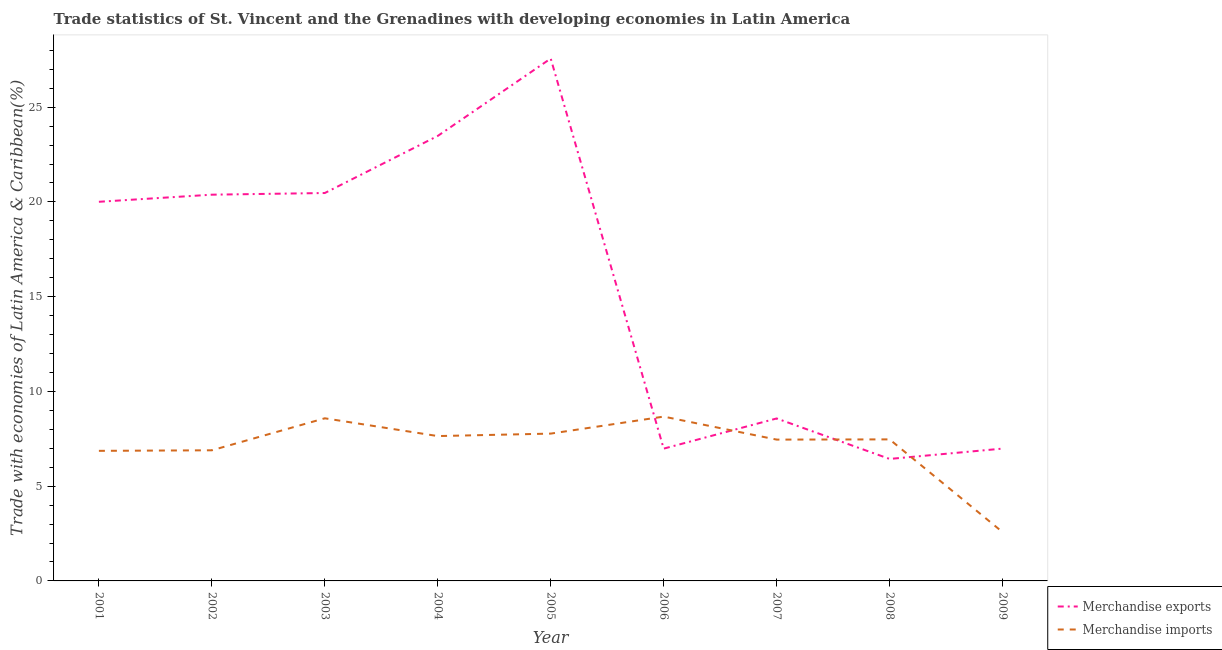Is the number of lines equal to the number of legend labels?
Offer a terse response. Yes. What is the merchandise imports in 2007?
Ensure brevity in your answer.  7.46. Across all years, what is the maximum merchandise imports?
Provide a succinct answer. 8.67. Across all years, what is the minimum merchandise imports?
Ensure brevity in your answer.  2.58. In which year was the merchandise imports maximum?
Offer a terse response. 2006. What is the total merchandise imports in the graph?
Make the answer very short. 63.94. What is the difference between the merchandise imports in 2003 and that in 2007?
Provide a short and direct response. 1.12. What is the difference between the merchandise imports in 2006 and the merchandise exports in 2001?
Your answer should be very brief. -11.34. What is the average merchandise exports per year?
Offer a very short reply. 15.65. In the year 2006, what is the difference between the merchandise exports and merchandise imports?
Your response must be concise. -1.69. In how many years, is the merchandise imports greater than 19 %?
Provide a short and direct response. 0. What is the ratio of the merchandise exports in 2001 to that in 2009?
Your answer should be very brief. 2.87. Is the merchandise imports in 2002 less than that in 2008?
Keep it short and to the point. Yes. What is the difference between the highest and the second highest merchandise exports?
Your response must be concise. 4.08. What is the difference between the highest and the lowest merchandise imports?
Your answer should be compact. 6.09. Is the sum of the merchandise exports in 2002 and 2008 greater than the maximum merchandise imports across all years?
Provide a succinct answer. Yes. Does the merchandise imports monotonically increase over the years?
Offer a terse response. No. How many years are there in the graph?
Your answer should be compact. 9. Are the values on the major ticks of Y-axis written in scientific E-notation?
Provide a short and direct response. No. Does the graph contain grids?
Offer a very short reply. No. What is the title of the graph?
Offer a very short reply. Trade statistics of St. Vincent and the Grenadines with developing economies in Latin America. What is the label or title of the X-axis?
Make the answer very short. Year. What is the label or title of the Y-axis?
Give a very brief answer. Trade with economies of Latin America & Caribbean(%). What is the Trade with economies of Latin America & Caribbean(%) in Merchandise exports in 2001?
Offer a terse response. 20.01. What is the Trade with economies of Latin America & Caribbean(%) in Merchandise imports in 2001?
Your answer should be very brief. 6.86. What is the Trade with economies of Latin America & Caribbean(%) in Merchandise exports in 2002?
Keep it short and to the point. 20.38. What is the Trade with economies of Latin America & Caribbean(%) in Merchandise imports in 2002?
Keep it short and to the point. 6.89. What is the Trade with economies of Latin America & Caribbean(%) in Merchandise exports in 2003?
Offer a very short reply. 20.47. What is the Trade with economies of Latin America & Caribbean(%) in Merchandise imports in 2003?
Give a very brief answer. 8.58. What is the Trade with economies of Latin America & Caribbean(%) of Merchandise exports in 2004?
Your answer should be compact. 23.48. What is the Trade with economies of Latin America & Caribbean(%) in Merchandise imports in 2004?
Keep it short and to the point. 7.64. What is the Trade with economies of Latin America & Caribbean(%) of Merchandise exports in 2005?
Make the answer very short. 27.57. What is the Trade with economies of Latin America & Caribbean(%) in Merchandise imports in 2005?
Offer a very short reply. 7.77. What is the Trade with economies of Latin America & Caribbean(%) of Merchandise exports in 2006?
Provide a short and direct response. 6.98. What is the Trade with economies of Latin America & Caribbean(%) of Merchandise imports in 2006?
Provide a succinct answer. 8.67. What is the Trade with economies of Latin America & Caribbean(%) of Merchandise exports in 2007?
Offer a very short reply. 8.57. What is the Trade with economies of Latin America & Caribbean(%) in Merchandise imports in 2007?
Your response must be concise. 7.46. What is the Trade with economies of Latin America & Caribbean(%) of Merchandise exports in 2008?
Give a very brief answer. 6.44. What is the Trade with economies of Latin America & Caribbean(%) of Merchandise imports in 2008?
Your response must be concise. 7.47. What is the Trade with economies of Latin America & Caribbean(%) in Merchandise exports in 2009?
Your response must be concise. 6.98. What is the Trade with economies of Latin America & Caribbean(%) in Merchandise imports in 2009?
Provide a short and direct response. 2.58. Across all years, what is the maximum Trade with economies of Latin America & Caribbean(%) in Merchandise exports?
Make the answer very short. 27.57. Across all years, what is the maximum Trade with economies of Latin America & Caribbean(%) in Merchandise imports?
Your answer should be compact. 8.67. Across all years, what is the minimum Trade with economies of Latin America & Caribbean(%) of Merchandise exports?
Make the answer very short. 6.44. Across all years, what is the minimum Trade with economies of Latin America & Caribbean(%) of Merchandise imports?
Provide a short and direct response. 2.58. What is the total Trade with economies of Latin America & Caribbean(%) of Merchandise exports in the graph?
Give a very brief answer. 140.89. What is the total Trade with economies of Latin America & Caribbean(%) of Merchandise imports in the graph?
Your answer should be very brief. 63.94. What is the difference between the Trade with economies of Latin America & Caribbean(%) in Merchandise exports in 2001 and that in 2002?
Keep it short and to the point. -0.37. What is the difference between the Trade with economies of Latin America & Caribbean(%) of Merchandise imports in 2001 and that in 2002?
Your answer should be very brief. -0.03. What is the difference between the Trade with economies of Latin America & Caribbean(%) in Merchandise exports in 2001 and that in 2003?
Ensure brevity in your answer.  -0.46. What is the difference between the Trade with economies of Latin America & Caribbean(%) in Merchandise imports in 2001 and that in 2003?
Provide a short and direct response. -1.72. What is the difference between the Trade with economies of Latin America & Caribbean(%) in Merchandise exports in 2001 and that in 2004?
Offer a very short reply. -3.48. What is the difference between the Trade with economies of Latin America & Caribbean(%) of Merchandise imports in 2001 and that in 2004?
Your answer should be very brief. -0.78. What is the difference between the Trade with economies of Latin America & Caribbean(%) of Merchandise exports in 2001 and that in 2005?
Provide a succinct answer. -7.56. What is the difference between the Trade with economies of Latin America & Caribbean(%) in Merchandise imports in 2001 and that in 2005?
Keep it short and to the point. -0.91. What is the difference between the Trade with economies of Latin America & Caribbean(%) of Merchandise exports in 2001 and that in 2006?
Provide a succinct answer. 13.03. What is the difference between the Trade with economies of Latin America & Caribbean(%) of Merchandise imports in 2001 and that in 2006?
Your answer should be very brief. -1.81. What is the difference between the Trade with economies of Latin America & Caribbean(%) in Merchandise exports in 2001 and that in 2007?
Make the answer very short. 11.44. What is the difference between the Trade with economies of Latin America & Caribbean(%) of Merchandise imports in 2001 and that in 2007?
Offer a terse response. -0.59. What is the difference between the Trade with economies of Latin America & Caribbean(%) in Merchandise exports in 2001 and that in 2008?
Offer a very short reply. 13.57. What is the difference between the Trade with economies of Latin America & Caribbean(%) in Merchandise imports in 2001 and that in 2008?
Provide a succinct answer. -0.6. What is the difference between the Trade with economies of Latin America & Caribbean(%) of Merchandise exports in 2001 and that in 2009?
Ensure brevity in your answer.  13.03. What is the difference between the Trade with economies of Latin America & Caribbean(%) of Merchandise imports in 2001 and that in 2009?
Your answer should be very brief. 4.29. What is the difference between the Trade with economies of Latin America & Caribbean(%) in Merchandise exports in 2002 and that in 2003?
Make the answer very short. -0.09. What is the difference between the Trade with economies of Latin America & Caribbean(%) of Merchandise imports in 2002 and that in 2003?
Your answer should be very brief. -1.69. What is the difference between the Trade with economies of Latin America & Caribbean(%) of Merchandise exports in 2002 and that in 2004?
Your response must be concise. -3.1. What is the difference between the Trade with economies of Latin America & Caribbean(%) in Merchandise imports in 2002 and that in 2004?
Keep it short and to the point. -0.75. What is the difference between the Trade with economies of Latin America & Caribbean(%) of Merchandise exports in 2002 and that in 2005?
Provide a succinct answer. -7.18. What is the difference between the Trade with economies of Latin America & Caribbean(%) of Merchandise imports in 2002 and that in 2005?
Make the answer very short. -0.88. What is the difference between the Trade with economies of Latin America & Caribbean(%) in Merchandise exports in 2002 and that in 2006?
Offer a very short reply. 13.4. What is the difference between the Trade with economies of Latin America & Caribbean(%) of Merchandise imports in 2002 and that in 2006?
Your answer should be compact. -1.78. What is the difference between the Trade with economies of Latin America & Caribbean(%) of Merchandise exports in 2002 and that in 2007?
Your answer should be compact. 11.81. What is the difference between the Trade with economies of Latin America & Caribbean(%) in Merchandise imports in 2002 and that in 2007?
Your answer should be compact. -0.56. What is the difference between the Trade with economies of Latin America & Caribbean(%) of Merchandise exports in 2002 and that in 2008?
Ensure brevity in your answer.  13.95. What is the difference between the Trade with economies of Latin America & Caribbean(%) in Merchandise imports in 2002 and that in 2008?
Make the answer very short. -0.58. What is the difference between the Trade with economies of Latin America & Caribbean(%) of Merchandise exports in 2002 and that in 2009?
Provide a short and direct response. 13.4. What is the difference between the Trade with economies of Latin America & Caribbean(%) of Merchandise imports in 2002 and that in 2009?
Your answer should be compact. 4.32. What is the difference between the Trade with economies of Latin America & Caribbean(%) of Merchandise exports in 2003 and that in 2004?
Your response must be concise. -3.01. What is the difference between the Trade with economies of Latin America & Caribbean(%) in Merchandise imports in 2003 and that in 2004?
Keep it short and to the point. 0.94. What is the difference between the Trade with economies of Latin America & Caribbean(%) of Merchandise exports in 2003 and that in 2005?
Ensure brevity in your answer.  -7.1. What is the difference between the Trade with economies of Latin America & Caribbean(%) in Merchandise imports in 2003 and that in 2005?
Offer a terse response. 0.81. What is the difference between the Trade with economies of Latin America & Caribbean(%) of Merchandise exports in 2003 and that in 2006?
Offer a terse response. 13.49. What is the difference between the Trade with economies of Latin America & Caribbean(%) in Merchandise imports in 2003 and that in 2006?
Give a very brief answer. -0.09. What is the difference between the Trade with economies of Latin America & Caribbean(%) in Merchandise exports in 2003 and that in 2007?
Offer a very short reply. 11.9. What is the difference between the Trade with economies of Latin America & Caribbean(%) in Merchandise imports in 2003 and that in 2007?
Your response must be concise. 1.12. What is the difference between the Trade with economies of Latin America & Caribbean(%) of Merchandise exports in 2003 and that in 2008?
Provide a succinct answer. 14.03. What is the difference between the Trade with economies of Latin America & Caribbean(%) in Merchandise imports in 2003 and that in 2008?
Your answer should be compact. 1.11. What is the difference between the Trade with economies of Latin America & Caribbean(%) of Merchandise exports in 2003 and that in 2009?
Your response must be concise. 13.49. What is the difference between the Trade with economies of Latin America & Caribbean(%) of Merchandise imports in 2003 and that in 2009?
Provide a succinct answer. 6.01. What is the difference between the Trade with economies of Latin America & Caribbean(%) in Merchandise exports in 2004 and that in 2005?
Make the answer very short. -4.08. What is the difference between the Trade with economies of Latin America & Caribbean(%) of Merchandise imports in 2004 and that in 2005?
Your answer should be compact. -0.13. What is the difference between the Trade with economies of Latin America & Caribbean(%) in Merchandise exports in 2004 and that in 2006?
Your response must be concise. 16.5. What is the difference between the Trade with economies of Latin America & Caribbean(%) in Merchandise imports in 2004 and that in 2006?
Your answer should be very brief. -1.03. What is the difference between the Trade with economies of Latin America & Caribbean(%) in Merchandise exports in 2004 and that in 2007?
Offer a terse response. 14.91. What is the difference between the Trade with economies of Latin America & Caribbean(%) of Merchandise imports in 2004 and that in 2007?
Provide a succinct answer. 0.19. What is the difference between the Trade with economies of Latin America & Caribbean(%) of Merchandise exports in 2004 and that in 2008?
Ensure brevity in your answer.  17.05. What is the difference between the Trade with economies of Latin America & Caribbean(%) of Merchandise imports in 2004 and that in 2008?
Ensure brevity in your answer.  0.17. What is the difference between the Trade with economies of Latin America & Caribbean(%) in Merchandise exports in 2004 and that in 2009?
Ensure brevity in your answer.  16.5. What is the difference between the Trade with economies of Latin America & Caribbean(%) in Merchandise imports in 2004 and that in 2009?
Offer a terse response. 5.07. What is the difference between the Trade with economies of Latin America & Caribbean(%) in Merchandise exports in 2005 and that in 2006?
Your answer should be very brief. 20.59. What is the difference between the Trade with economies of Latin America & Caribbean(%) in Merchandise imports in 2005 and that in 2006?
Make the answer very short. -0.9. What is the difference between the Trade with economies of Latin America & Caribbean(%) in Merchandise exports in 2005 and that in 2007?
Ensure brevity in your answer.  18.99. What is the difference between the Trade with economies of Latin America & Caribbean(%) of Merchandise imports in 2005 and that in 2007?
Offer a very short reply. 0.32. What is the difference between the Trade with economies of Latin America & Caribbean(%) of Merchandise exports in 2005 and that in 2008?
Ensure brevity in your answer.  21.13. What is the difference between the Trade with economies of Latin America & Caribbean(%) in Merchandise imports in 2005 and that in 2008?
Make the answer very short. 0.3. What is the difference between the Trade with economies of Latin America & Caribbean(%) in Merchandise exports in 2005 and that in 2009?
Ensure brevity in your answer.  20.58. What is the difference between the Trade with economies of Latin America & Caribbean(%) of Merchandise imports in 2005 and that in 2009?
Your answer should be compact. 5.2. What is the difference between the Trade with economies of Latin America & Caribbean(%) in Merchandise exports in 2006 and that in 2007?
Make the answer very short. -1.59. What is the difference between the Trade with economies of Latin America & Caribbean(%) in Merchandise imports in 2006 and that in 2007?
Make the answer very short. 1.21. What is the difference between the Trade with economies of Latin America & Caribbean(%) of Merchandise exports in 2006 and that in 2008?
Your answer should be compact. 0.54. What is the difference between the Trade with economies of Latin America & Caribbean(%) in Merchandise imports in 2006 and that in 2008?
Offer a terse response. 1.2. What is the difference between the Trade with economies of Latin America & Caribbean(%) of Merchandise exports in 2006 and that in 2009?
Keep it short and to the point. -0. What is the difference between the Trade with economies of Latin America & Caribbean(%) of Merchandise imports in 2006 and that in 2009?
Offer a very short reply. 6.09. What is the difference between the Trade with economies of Latin America & Caribbean(%) of Merchandise exports in 2007 and that in 2008?
Provide a succinct answer. 2.14. What is the difference between the Trade with economies of Latin America & Caribbean(%) in Merchandise imports in 2007 and that in 2008?
Provide a succinct answer. -0.01. What is the difference between the Trade with economies of Latin America & Caribbean(%) of Merchandise exports in 2007 and that in 2009?
Offer a terse response. 1.59. What is the difference between the Trade with economies of Latin America & Caribbean(%) in Merchandise imports in 2007 and that in 2009?
Make the answer very short. 4.88. What is the difference between the Trade with economies of Latin America & Caribbean(%) in Merchandise exports in 2008 and that in 2009?
Make the answer very short. -0.54. What is the difference between the Trade with economies of Latin America & Caribbean(%) in Merchandise imports in 2008 and that in 2009?
Make the answer very short. 4.89. What is the difference between the Trade with economies of Latin America & Caribbean(%) of Merchandise exports in 2001 and the Trade with economies of Latin America & Caribbean(%) of Merchandise imports in 2002?
Ensure brevity in your answer.  13.11. What is the difference between the Trade with economies of Latin America & Caribbean(%) of Merchandise exports in 2001 and the Trade with economies of Latin America & Caribbean(%) of Merchandise imports in 2003?
Keep it short and to the point. 11.43. What is the difference between the Trade with economies of Latin America & Caribbean(%) in Merchandise exports in 2001 and the Trade with economies of Latin America & Caribbean(%) in Merchandise imports in 2004?
Give a very brief answer. 12.36. What is the difference between the Trade with economies of Latin America & Caribbean(%) of Merchandise exports in 2001 and the Trade with economies of Latin America & Caribbean(%) of Merchandise imports in 2005?
Provide a succinct answer. 12.23. What is the difference between the Trade with economies of Latin America & Caribbean(%) of Merchandise exports in 2001 and the Trade with economies of Latin America & Caribbean(%) of Merchandise imports in 2006?
Provide a short and direct response. 11.34. What is the difference between the Trade with economies of Latin America & Caribbean(%) of Merchandise exports in 2001 and the Trade with economies of Latin America & Caribbean(%) of Merchandise imports in 2007?
Your answer should be very brief. 12.55. What is the difference between the Trade with economies of Latin America & Caribbean(%) of Merchandise exports in 2001 and the Trade with economies of Latin America & Caribbean(%) of Merchandise imports in 2008?
Keep it short and to the point. 12.54. What is the difference between the Trade with economies of Latin America & Caribbean(%) in Merchandise exports in 2001 and the Trade with economies of Latin America & Caribbean(%) in Merchandise imports in 2009?
Keep it short and to the point. 17.43. What is the difference between the Trade with economies of Latin America & Caribbean(%) of Merchandise exports in 2002 and the Trade with economies of Latin America & Caribbean(%) of Merchandise imports in 2003?
Offer a very short reply. 11.8. What is the difference between the Trade with economies of Latin America & Caribbean(%) of Merchandise exports in 2002 and the Trade with economies of Latin America & Caribbean(%) of Merchandise imports in 2004?
Provide a succinct answer. 12.74. What is the difference between the Trade with economies of Latin America & Caribbean(%) of Merchandise exports in 2002 and the Trade with economies of Latin America & Caribbean(%) of Merchandise imports in 2005?
Your answer should be very brief. 12.61. What is the difference between the Trade with economies of Latin America & Caribbean(%) of Merchandise exports in 2002 and the Trade with economies of Latin America & Caribbean(%) of Merchandise imports in 2006?
Provide a succinct answer. 11.71. What is the difference between the Trade with economies of Latin America & Caribbean(%) in Merchandise exports in 2002 and the Trade with economies of Latin America & Caribbean(%) in Merchandise imports in 2007?
Provide a short and direct response. 12.93. What is the difference between the Trade with economies of Latin America & Caribbean(%) in Merchandise exports in 2002 and the Trade with economies of Latin America & Caribbean(%) in Merchandise imports in 2008?
Keep it short and to the point. 12.91. What is the difference between the Trade with economies of Latin America & Caribbean(%) in Merchandise exports in 2002 and the Trade with economies of Latin America & Caribbean(%) in Merchandise imports in 2009?
Offer a terse response. 17.81. What is the difference between the Trade with economies of Latin America & Caribbean(%) of Merchandise exports in 2003 and the Trade with economies of Latin America & Caribbean(%) of Merchandise imports in 2004?
Offer a terse response. 12.83. What is the difference between the Trade with economies of Latin America & Caribbean(%) of Merchandise exports in 2003 and the Trade with economies of Latin America & Caribbean(%) of Merchandise imports in 2005?
Give a very brief answer. 12.7. What is the difference between the Trade with economies of Latin America & Caribbean(%) in Merchandise exports in 2003 and the Trade with economies of Latin America & Caribbean(%) in Merchandise imports in 2006?
Your answer should be compact. 11.8. What is the difference between the Trade with economies of Latin America & Caribbean(%) of Merchandise exports in 2003 and the Trade with economies of Latin America & Caribbean(%) of Merchandise imports in 2007?
Your answer should be compact. 13.01. What is the difference between the Trade with economies of Latin America & Caribbean(%) in Merchandise exports in 2003 and the Trade with economies of Latin America & Caribbean(%) in Merchandise imports in 2008?
Keep it short and to the point. 13. What is the difference between the Trade with economies of Latin America & Caribbean(%) of Merchandise exports in 2003 and the Trade with economies of Latin America & Caribbean(%) of Merchandise imports in 2009?
Ensure brevity in your answer.  17.89. What is the difference between the Trade with economies of Latin America & Caribbean(%) in Merchandise exports in 2004 and the Trade with economies of Latin America & Caribbean(%) in Merchandise imports in 2005?
Provide a succinct answer. 15.71. What is the difference between the Trade with economies of Latin America & Caribbean(%) in Merchandise exports in 2004 and the Trade with economies of Latin America & Caribbean(%) in Merchandise imports in 2006?
Ensure brevity in your answer.  14.81. What is the difference between the Trade with economies of Latin America & Caribbean(%) of Merchandise exports in 2004 and the Trade with economies of Latin America & Caribbean(%) of Merchandise imports in 2007?
Give a very brief answer. 16.03. What is the difference between the Trade with economies of Latin America & Caribbean(%) of Merchandise exports in 2004 and the Trade with economies of Latin America & Caribbean(%) of Merchandise imports in 2008?
Your answer should be compact. 16.02. What is the difference between the Trade with economies of Latin America & Caribbean(%) of Merchandise exports in 2004 and the Trade with economies of Latin America & Caribbean(%) of Merchandise imports in 2009?
Give a very brief answer. 20.91. What is the difference between the Trade with economies of Latin America & Caribbean(%) of Merchandise exports in 2005 and the Trade with economies of Latin America & Caribbean(%) of Merchandise imports in 2006?
Provide a short and direct response. 18.9. What is the difference between the Trade with economies of Latin America & Caribbean(%) in Merchandise exports in 2005 and the Trade with economies of Latin America & Caribbean(%) in Merchandise imports in 2007?
Offer a very short reply. 20.11. What is the difference between the Trade with economies of Latin America & Caribbean(%) of Merchandise exports in 2005 and the Trade with economies of Latin America & Caribbean(%) of Merchandise imports in 2008?
Offer a terse response. 20.1. What is the difference between the Trade with economies of Latin America & Caribbean(%) in Merchandise exports in 2005 and the Trade with economies of Latin America & Caribbean(%) in Merchandise imports in 2009?
Your answer should be compact. 24.99. What is the difference between the Trade with economies of Latin America & Caribbean(%) in Merchandise exports in 2006 and the Trade with economies of Latin America & Caribbean(%) in Merchandise imports in 2007?
Offer a very short reply. -0.48. What is the difference between the Trade with economies of Latin America & Caribbean(%) of Merchandise exports in 2006 and the Trade with economies of Latin America & Caribbean(%) of Merchandise imports in 2008?
Your answer should be compact. -0.49. What is the difference between the Trade with economies of Latin America & Caribbean(%) in Merchandise exports in 2006 and the Trade with economies of Latin America & Caribbean(%) in Merchandise imports in 2009?
Your answer should be compact. 4.4. What is the difference between the Trade with economies of Latin America & Caribbean(%) in Merchandise exports in 2007 and the Trade with economies of Latin America & Caribbean(%) in Merchandise imports in 2008?
Offer a terse response. 1.1. What is the difference between the Trade with economies of Latin America & Caribbean(%) of Merchandise exports in 2007 and the Trade with economies of Latin America & Caribbean(%) of Merchandise imports in 2009?
Your answer should be compact. 6. What is the difference between the Trade with economies of Latin America & Caribbean(%) in Merchandise exports in 2008 and the Trade with economies of Latin America & Caribbean(%) in Merchandise imports in 2009?
Your answer should be compact. 3.86. What is the average Trade with economies of Latin America & Caribbean(%) of Merchandise exports per year?
Your answer should be compact. 15.65. What is the average Trade with economies of Latin America & Caribbean(%) in Merchandise imports per year?
Give a very brief answer. 7.1. In the year 2001, what is the difference between the Trade with economies of Latin America & Caribbean(%) in Merchandise exports and Trade with economies of Latin America & Caribbean(%) in Merchandise imports?
Your answer should be compact. 13.14. In the year 2002, what is the difference between the Trade with economies of Latin America & Caribbean(%) of Merchandise exports and Trade with economies of Latin America & Caribbean(%) of Merchandise imports?
Provide a succinct answer. 13.49. In the year 2003, what is the difference between the Trade with economies of Latin America & Caribbean(%) in Merchandise exports and Trade with economies of Latin America & Caribbean(%) in Merchandise imports?
Give a very brief answer. 11.89. In the year 2004, what is the difference between the Trade with economies of Latin America & Caribbean(%) of Merchandise exports and Trade with economies of Latin America & Caribbean(%) of Merchandise imports?
Offer a terse response. 15.84. In the year 2005, what is the difference between the Trade with economies of Latin America & Caribbean(%) of Merchandise exports and Trade with economies of Latin America & Caribbean(%) of Merchandise imports?
Offer a very short reply. 19.79. In the year 2006, what is the difference between the Trade with economies of Latin America & Caribbean(%) in Merchandise exports and Trade with economies of Latin America & Caribbean(%) in Merchandise imports?
Offer a very short reply. -1.69. In the year 2007, what is the difference between the Trade with economies of Latin America & Caribbean(%) in Merchandise exports and Trade with economies of Latin America & Caribbean(%) in Merchandise imports?
Your answer should be very brief. 1.12. In the year 2008, what is the difference between the Trade with economies of Latin America & Caribbean(%) in Merchandise exports and Trade with economies of Latin America & Caribbean(%) in Merchandise imports?
Offer a terse response. -1.03. In the year 2009, what is the difference between the Trade with economies of Latin America & Caribbean(%) of Merchandise exports and Trade with economies of Latin America & Caribbean(%) of Merchandise imports?
Give a very brief answer. 4.41. What is the ratio of the Trade with economies of Latin America & Caribbean(%) of Merchandise exports in 2001 to that in 2002?
Provide a succinct answer. 0.98. What is the ratio of the Trade with economies of Latin America & Caribbean(%) of Merchandise imports in 2001 to that in 2002?
Keep it short and to the point. 1. What is the ratio of the Trade with economies of Latin America & Caribbean(%) of Merchandise exports in 2001 to that in 2003?
Ensure brevity in your answer.  0.98. What is the ratio of the Trade with economies of Latin America & Caribbean(%) of Merchandise imports in 2001 to that in 2003?
Your answer should be compact. 0.8. What is the ratio of the Trade with economies of Latin America & Caribbean(%) of Merchandise exports in 2001 to that in 2004?
Provide a short and direct response. 0.85. What is the ratio of the Trade with economies of Latin America & Caribbean(%) of Merchandise imports in 2001 to that in 2004?
Offer a terse response. 0.9. What is the ratio of the Trade with economies of Latin America & Caribbean(%) in Merchandise exports in 2001 to that in 2005?
Keep it short and to the point. 0.73. What is the ratio of the Trade with economies of Latin America & Caribbean(%) of Merchandise imports in 2001 to that in 2005?
Make the answer very short. 0.88. What is the ratio of the Trade with economies of Latin America & Caribbean(%) in Merchandise exports in 2001 to that in 2006?
Your response must be concise. 2.87. What is the ratio of the Trade with economies of Latin America & Caribbean(%) in Merchandise imports in 2001 to that in 2006?
Keep it short and to the point. 0.79. What is the ratio of the Trade with economies of Latin America & Caribbean(%) in Merchandise exports in 2001 to that in 2007?
Offer a terse response. 2.33. What is the ratio of the Trade with economies of Latin America & Caribbean(%) in Merchandise imports in 2001 to that in 2007?
Ensure brevity in your answer.  0.92. What is the ratio of the Trade with economies of Latin America & Caribbean(%) of Merchandise exports in 2001 to that in 2008?
Give a very brief answer. 3.11. What is the ratio of the Trade with economies of Latin America & Caribbean(%) in Merchandise imports in 2001 to that in 2008?
Keep it short and to the point. 0.92. What is the ratio of the Trade with economies of Latin America & Caribbean(%) in Merchandise exports in 2001 to that in 2009?
Offer a terse response. 2.87. What is the ratio of the Trade with economies of Latin America & Caribbean(%) in Merchandise imports in 2001 to that in 2009?
Give a very brief answer. 2.66. What is the ratio of the Trade with economies of Latin America & Caribbean(%) of Merchandise exports in 2002 to that in 2003?
Your answer should be compact. 1. What is the ratio of the Trade with economies of Latin America & Caribbean(%) of Merchandise imports in 2002 to that in 2003?
Your response must be concise. 0.8. What is the ratio of the Trade with economies of Latin America & Caribbean(%) of Merchandise exports in 2002 to that in 2004?
Provide a succinct answer. 0.87. What is the ratio of the Trade with economies of Latin America & Caribbean(%) of Merchandise imports in 2002 to that in 2004?
Your response must be concise. 0.9. What is the ratio of the Trade with economies of Latin America & Caribbean(%) in Merchandise exports in 2002 to that in 2005?
Make the answer very short. 0.74. What is the ratio of the Trade with economies of Latin America & Caribbean(%) in Merchandise imports in 2002 to that in 2005?
Your response must be concise. 0.89. What is the ratio of the Trade with economies of Latin America & Caribbean(%) of Merchandise exports in 2002 to that in 2006?
Offer a terse response. 2.92. What is the ratio of the Trade with economies of Latin America & Caribbean(%) of Merchandise imports in 2002 to that in 2006?
Your answer should be very brief. 0.79. What is the ratio of the Trade with economies of Latin America & Caribbean(%) in Merchandise exports in 2002 to that in 2007?
Provide a succinct answer. 2.38. What is the ratio of the Trade with economies of Latin America & Caribbean(%) of Merchandise imports in 2002 to that in 2007?
Ensure brevity in your answer.  0.92. What is the ratio of the Trade with economies of Latin America & Caribbean(%) in Merchandise exports in 2002 to that in 2008?
Offer a very short reply. 3.17. What is the ratio of the Trade with economies of Latin America & Caribbean(%) in Merchandise imports in 2002 to that in 2008?
Your answer should be very brief. 0.92. What is the ratio of the Trade with economies of Latin America & Caribbean(%) of Merchandise exports in 2002 to that in 2009?
Make the answer very short. 2.92. What is the ratio of the Trade with economies of Latin America & Caribbean(%) of Merchandise imports in 2002 to that in 2009?
Your response must be concise. 2.67. What is the ratio of the Trade with economies of Latin America & Caribbean(%) in Merchandise exports in 2003 to that in 2004?
Your answer should be compact. 0.87. What is the ratio of the Trade with economies of Latin America & Caribbean(%) of Merchandise imports in 2003 to that in 2004?
Provide a short and direct response. 1.12. What is the ratio of the Trade with economies of Latin America & Caribbean(%) in Merchandise exports in 2003 to that in 2005?
Your answer should be compact. 0.74. What is the ratio of the Trade with economies of Latin America & Caribbean(%) of Merchandise imports in 2003 to that in 2005?
Your answer should be compact. 1.1. What is the ratio of the Trade with economies of Latin America & Caribbean(%) in Merchandise exports in 2003 to that in 2006?
Your response must be concise. 2.93. What is the ratio of the Trade with economies of Latin America & Caribbean(%) in Merchandise imports in 2003 to that in 2006?
Your answer should be compact. 0.99. What is the ratio of the Trade with economies of Latin America & Caribbean(%) of Merchandise exports in 2003 to that in 2007?
Give a very brief answer. 2.39. What is the ratio of the Trade with economies of Latin America & Caribbean(%) of Merchandise imports in 2003 to that in 2007?
Your answer should be very brief. 1.15. What is the ratio of the Trade with economies of Latin America & Caribbean(%) in Merchandise exports in 2003 to that in 2008?
Keep it short and to the point. 3.18. What is the ratio of the Trade with economies of Latin America & Caribbean(%) in Merchandise imports in 2003 to that in 2008?
Offer a very short reply. 1.15. What is the ratio of the Trade with economies of Latin America & Caribbean(%) of Merchandise exports in 2003 to that in 2009?
Make the answer very short. 2.93. What is the ratio of the Trade with economies of Latin America & Caribbean(%) of Merchandise imports in 2003 to that in 2009?
Your answer should be very brief. 3.33. What is the ratio of the Trade with economies of Latin America & Caribbean(%) in Merchandise exports in 2004 to that in 2005?
Your answer should be compact. 0.85. What is the ratio of the Trade with economies of Latin America & Caribbean(%) of Merchandise imports in 2004 to that in 2005?
Provide a short and direct response. 0.98. What is the ratio of the Trade with economies of Latin America & Caribbean(%) in Merchandise exports in 2004 to that in 2006?
Offer a terse response. 3.36. What is the ratio of the Trade with economies of Latin America & Caribbean(%) in Merchandise imports in 2004 to that in 2006?
Your answer should be compact. 0.88. What is the ratio of the Trade with economies of Latin America & Caribbean(%) of Merchandise exports in 2004 to that in 2007?
Your response must be concise. 2.74. What is the ratio of the Trade with economies of Latin America & Caribbean(%) in Merchandise exports in 2004 to that in 2008?
Your response must be concise. 3.65. What is the ratio of the Trade with economies of Latin America & Caribbean(%) in Merchandise imports in 2004 to that in 2008?
Make the answer very short. 1.02. What is the ratio of the Trade with economies of Latin America & Caribbean(%) of Merchandise exports in 2004 to that in 2009?
Your answer should be very brief. 3.36. What is the ratio of the Trade with economies of Latin America & Caribbean(%) of Merchandise imports in 2004 to that in 2009?
Give a very brief answer. 2.97. What is the ratio of the Trade with economies of Latin America & Caribbean(%) of Merchandise exports in 2005 to that in 2006?
Make the answer very short. 3.95. What is the ratio of the Trade with economies of Latin America & Caribbean(%) of Merchandise imports in 2005 to that in 2006?
Your response must be concise. 0.9. What is the ratio of the Trade with economies of Latin America & Caribbean(%) in Merchandise exports in 2005 to that in 2007?
Offer a very short reply. 3.22. What is the ratio of the Trade with economies of Latin America & Caribbean(%) of Merchandise imports in 2005 to that in 2007?
Provide a succinct answer. 1.04. What is the ratio of the Trade with economies of Latin America & Caribbean(%) in Merchandise exports in 2005 to that in 2008?
Provide a short and direct response. 4.28. What is the ratio of the Trade with economies of Latin America & Caribbean(%) of Merchandise imports in 2005 to that in 2008?
Ensure brevity in your answer.  1.04. What is the ratio of the Trade with economies of Latin America & Caribbean(%) in Merchandise exports in 2005 to that in 2009?
Provide a succinct answer. 3.95. What is the ratio of the Trade with economies of Latin America & Caribbean(%) of Merchandise imports in 2005 to that in 2009?
Offer a terse response. 3.02. What is the ratio of the Trade with economies of Latin America & Caribbean(%) of Merchandise exports in 2006 to that in 2007?
Ensure brevity in your answer.  0.81. What is the ratio of the Trade with economies of Latin America & Caribbean(%) in Merchandise imports in 2006 to that in 2007?
Provide a succinct answer. 1.16. What is the ratio of the Trade with economies of Latin America & Caribbean(%) in Merchandise exports in 2006 to that in 2008?
Offer a terse response. 1.08. What is the ratio of the Trade with economies of Latin America & Caribbean(%) of Merchandise imports in 2006 to that in 2008?
Ensure brevity in your answer.  1.16. What is the ratio of the Trade with economies of Latin America & Caribbean(%) of Merchandise exports in 2006 to that in 2009?
Make the answer very short. 1. What is the ratio of the Trade with economies of Latin America & Caribbean(%) in Merchandise imports in 2006 to that in 2009?
Your response must be concise. 3.36. What is the ratio of the Trade with economies of Latin America & Caribbean(%) of Merchandise exports in 2007 to that in 2008?
Provide a short and direct response. 1.33. What is the ratio of the Trade with economies of Latin America & Caribbean(%) in Merchandise exports in 2007 to that in 2009?
Ensure brevity in your answer.  1.23. What is the ratio of the Trade with economies of Latin America & Caribbean(%) of Merchandise imports in 2007 to that in 2009?
Keep it short and to the point. 2.89. What is the ratio of the Trade with economies of Latin America & Caribbean(%) in Merchandise exports in 2008 to that in 2009?
Offer a terse response. 0.92. What is the ratio of the Trade with economies of Latin America & Caribbean(%) of Merchandise imports in 2008 to that in 2009?
Ensure brevity in your answer.  2.9. What is the difference between the highest and the second highest Trade with economies of Latin America & Caribbean(%) of Merchandise exports?
Ensure brevity in your answer.  4.08. What is the difference between the highest and the second highest Trade with economies of Latin America & Caribbean(%) in Merchandise imports?
Your response must be concise. 0.09. What is the difference between the highest and the lowest Trade with economies of Latin America & Caribbean(%) of Merchandise exports?
Provide a short and direct response. 21.13. What is the difference between the highest and the lowest Trade with economies of Latin America & Caribbean(%) in Merchandise imports?
Offer a terse response. 6.09. 